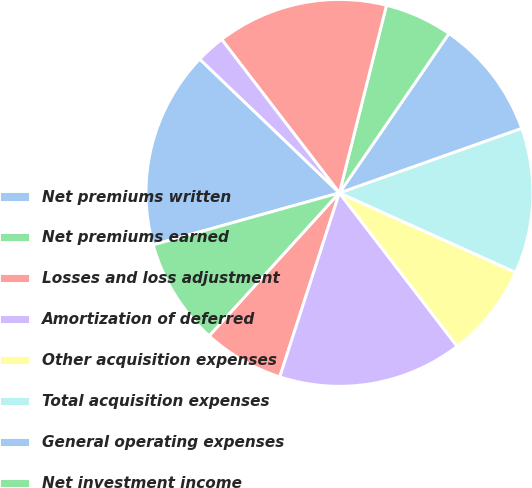Convert chart. <chart><loc_0><loc_0><loc_500><loc_500><pie_chart><fcel>Net premiums written<fcel>Net premiums earned<fcel>Losses and loss adjustment<fcel>Amortization of deferred<fcel>Other acquisition expenses<fcel>Total acquisition expenses<fcel>General operating expenses<fcel>Net investment income<fcel>Loss ratio ^(a)<fcel>Acquisition ratio<nl><fcel>16.49%<fcel>8.92%<fcel>6.76%<fcel>15.41%<fcel>7.84%<fcel>12.16%<fcel>10.0%<fcel>5.67%<fcel>14.33%<fcel>2.43%<nl></chart> 